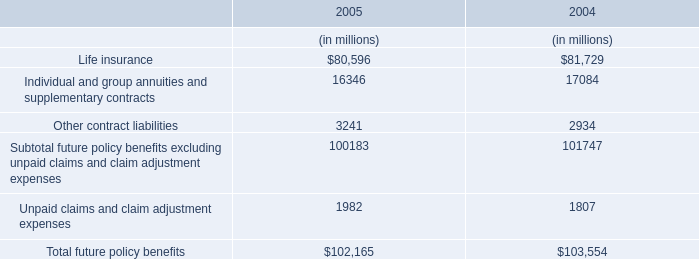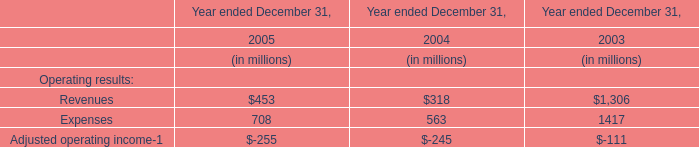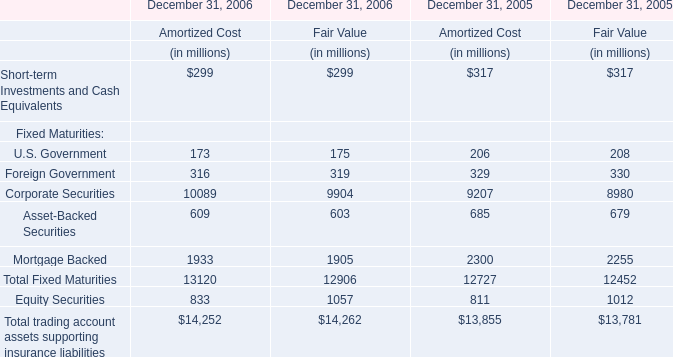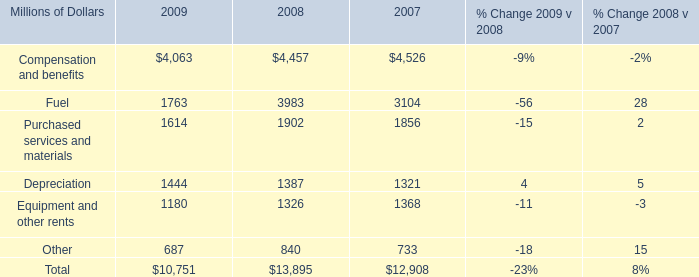what was the average yearly decline in international traffic in 2008 and in 2009? 
Computations: ((11% + 24%) / 2)
Answer: 0.175. 